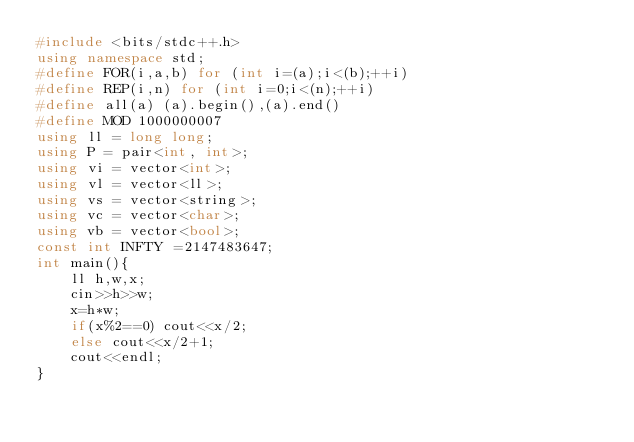<code> <loc_0><loc_0><loc_500><loc_500><_C++_>#include <bits/stdc++.h>
using namespace std;
#define FOR(i,a,b) for (int i=(a);i<(b);++i)
#define REP(i,n) for (int i=0;i<(n);++i)
#define all(a) (a).begin(),(a).end()
#define MOD 1000000007
using ll = long long;
using P = pair<int, int>;
using vi = vector<int>;
using vl = vector<ll>;
using vs = vector<string>;
using vc = vector<char>;
using vb = vector<bool>;
const int INFTY =2147483647;
int main(){
    ll h,w,x;
    cin>>h>>w;
    x=h*w;
    if(x%2==0) cout<<x/2;
    else cout<<x/2+1;
    cout<<endl;
}</code> 